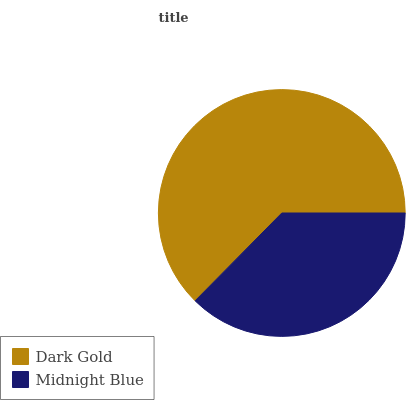Is Midnight Blue the minimum?
Answer yes or no. Yes. Is Dark Gold the maximum?
Answer yes or no. Yes. Is Midnight Blue the maximum?
Answer yes or no. No. Is Dark Gold greater than Midnight Blue?
Answer yes or no. Yes. Is Midnight Blue less than Dark Gold?
Answer yes or no. Yes. Is Midnight Blue greater than Dark Gold?
Answer yes or no. No. Is Dark Gold less than Midnight Blue?
Answer yes or no. No. Is Dark Gold the high median?
Answer yes or no. Yes. Is Midnight Blue the low median?
Answer yes or no. Yes. Is Midnight Blue the high median?
Answer yes or no. No. Is Dark Gold the low median?
Answer yes or no. No. 